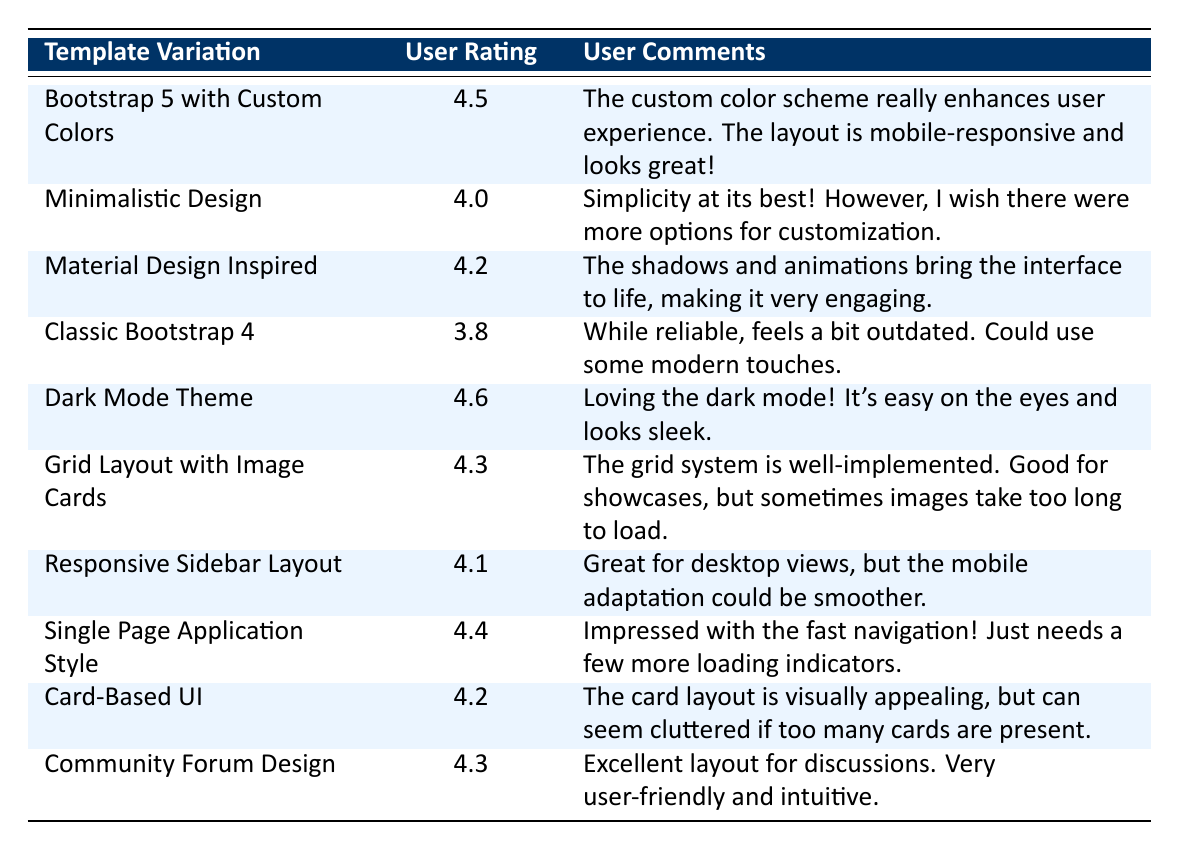What is the user rating for the "Dark Mode Theme"? The table lists the user rating for each template variation, and the "Dark Mode Theme" has a user rating of 4.6.
Answer: 4.6 Which template variation received the lowest user rating? By examining the user ratings, "Classic Bootstrap 4" has the lowest rating at 3.8 among all the entries in the table.
Answer: Classic Bootstrap 4 What is the average user rating for all template variations? To calculate the average, first sum the ratings: (4.5 + 4.0 + 4.2 + 3.8 + 4.6 + 4.3 + 4.1 + 4.4 + 4.2 + 4.3) = 43.4. There are 10 ratings, so the average is 43.4 / 10 = 4.34.
Answer: 4.34 Did any template variation receive a rating of 5.0? No entries in the table have a rating of 5.0; all ratings are below that value.
Answer: No Which template variation has comments highlighting good user experience? The "Bootstrap 5 with Custom Colors" and "Dark Mode Theme" both have comments that mention enhancing user experience. Specifically, the "Dark Mode Theme" is praised for being easy on the eyes.
Answer: Bootstrap 5 with Custom Colors, Dark Mode Theme How many template variations have a user rating above 4.0? There are seven template variations with ratings above 4.0: "Bootstrap 5 with Custom Colors," "Minimalistic Design," "Material Design Inspired," "Dark Mode Theme," "Grid Layout with Image Cards," "Single Page Application Style," and "Community Forum Design."
Answer: 7 What is the user rating difference between "Responsive Sidebar Layout" and "Classic Bootstrap 4"? The "Responsive Sidebar Layout" has a rating of 4.1, while "Classic Bootstrap 4" has a rating of 3.8. The difference is 4.1 - 3.8 = 0.3.
Answer: 0.3 Is the "Material Design Inspired" template rated higher than the "Card-Based UI"? "Material Design Inspired" has a rating of 4.2, while "Card-Based UI" also has a rating of 4.2. Thus, they are rated equally, and neither is higher than the other.
Answer: No Which template variation was noted for its engaging interface? The "Material Design Inspired" template variation is noted for its engaging interface due to its shadows and animations that bring it to life.
Answer: Material Design Inspired 